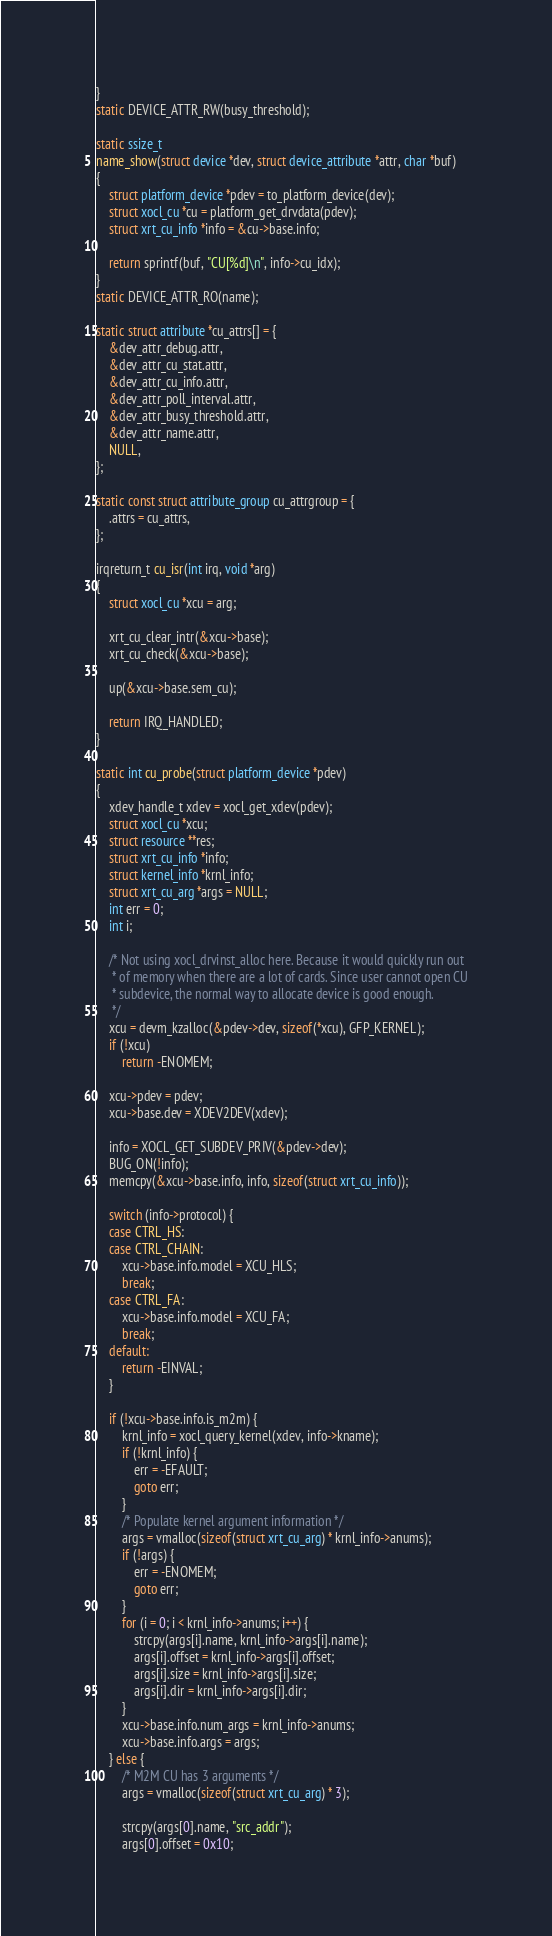Convert code to text. <code><loc_0><loc_0><loc_500><loc_500><_C_>}
static DEVICE_ATTR_RW(busy_threshold);

static ssize_t
name_show(struct device *dev, struct device_attribute *attr, char *buf)
{
	struct platform_device *pdev = to_platform_device(dev);
	struct xocl_cu *cu = platform_get_drvdata(pdev);
	struct xrt_cu_info *info = &cu->base.info;

	return sprintf(buf, "CU[%d]\n", info->cu_idx);
}
static DEVICE_ATTR_RO(name);

static struct attribute *cu_attrs[] = {
	&dev_attr_debug.attr,
	&dev_attr_cu_stat.attr,
	&dev_attr_cu_info.attr,
	&dev_attr_poll_interval.attr,
	&dev_attr_busy_threshold.attr,
	&dev_attr_name.attr,
	NULL,
};

static const struct attribute_group cu_attrgroup = {
	.attrs = cu_attrs,
};

irqreturn_t cu_isr(int irq, void *arg)
{
	struct xocl_cu *xcu = arg;

	xrt_cu_clear_intr(&xcu->base);
	xrt_cu_check(&xcu->base);

	up(&xcu->base.sem_cu);

	return IRQ_HANDLED;
}

static int cu_probe(struct platform_device *pdev)
{
	xdev_handle_t xdev = xocl_get_xdev(pdev);
	struct xocl_cu *xcu;
	struct resource **res;
	struct xrt_cu_info *info;
	struct kernel_info *krnl_info;
	struct xrt_cu_arg *args = NULL;
	int err = 0;
	int i;

	/* Not using xocl_drvinst_alloc here. Because it would quickly run out
	 * of memory when there are a lot of cards. Since user cannot open CU
	 * subdevice, the normal way to allocate device is good enough.
	 */
	xcu = devm_kzalloc(&pdev->dev, sizeof(*xcu), GFP_KERNEL);
	if (!xcu)
		return -ENOMEM;

	xcu->pdev = pdev;
	xcu->base.dev = XDEV2DEV(xdev);

	info = XOCL_GET_SUBDEV_PRIV(&pdev->dev);
	BUG_ON(!info);
	memcpy(&xcu->base.info, info, sizeof(struct xrt_cu_info));

	switch (info->protocol) {
	case CTRL_HS:
	case CTRL_CHAIN:
		xcu->base.info.model = XCU_HLS;
		break;
	case CTRL_FA:
		xcu->base.info.model = XCU_FA;
		break;
	default:
		return -EINVAL;
	}

	if (!xcu->base.info.is_m2m) {
		krnl_info = xocl_query_kernel(xdev, info->kname);
		if (!krnl_info) {
			err = -EFAULT;
			goto err;
		}
		/* Populate kernel argument information */
		args = vmalloc(sizeof(struct xrt_cu_arg) * krnl_info->anums);
		if (!args) {
			err = -ENOMEM;
			goto err;
		}
		for (i = 0; i < krnl_info->anums; i++) {
			strcpy(args[i].name, krnl_info->args[i].name);
			args[i].offset = krnl_info->args[i].offset;
			args[i].size = krnl_info->args[i].size;
			args[i].dir = krnl_info->args[i].dir;
		}
		xcu->base.info.num_args = krnl_info->anums;
		xcu->base.info.args = args;
	} else {
		/* M2M CU has 3 arguments */
		args = vmalloc(sizeof(struct xrt_cu_arg) * 3);

		strcpy(args[0].name, "src_addr");
		args[0].offset = 0x10;</code> 